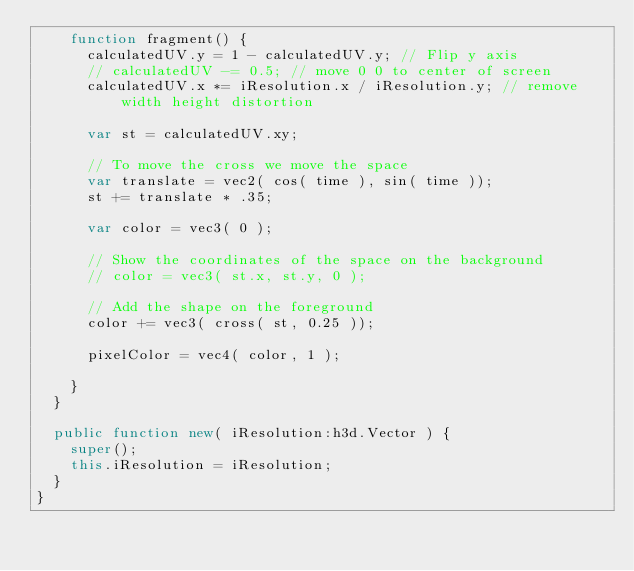<code> <loc_0><loc_0><loc_500><loc_500><_Haxe_>		function fragment() {
			calculatedUV.y = 1 - calculatedUV.y; // Flip y axis
			// calculatedUV -= 0.5; // move 0 0 to center of screen
			calculatedUV.x *= iResolution.x / iResolution.y; // remove width height distortion
			
			var st = calculatedUV.xy;
			
			// To move the cross we move the space
			var translate = vec2( cos( time ), sin( time ));
			st += translate * .35;

			var color = vec3( 0 );
			
			// Show the coordinates of the space on the background
			// color = vec3( st.x, st.y, 0 );

			// Add the shape on the foreground
			color += vec3( cross( st, 0.25 ));

			pixelColor = vec4( color, 1 );

		}
	}
	
	public function new( iResolution:h3d.Vector ) {
		super();
		this.iResolution = iResolution;
	}
}</code> 